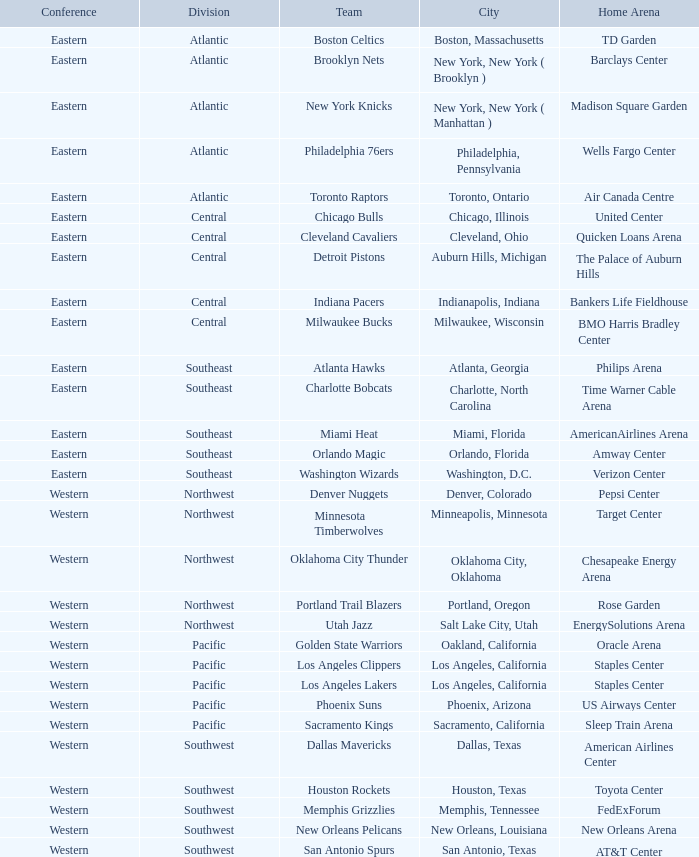Which urban area contains barclays center? New York, New York ( Brooklyn ). 